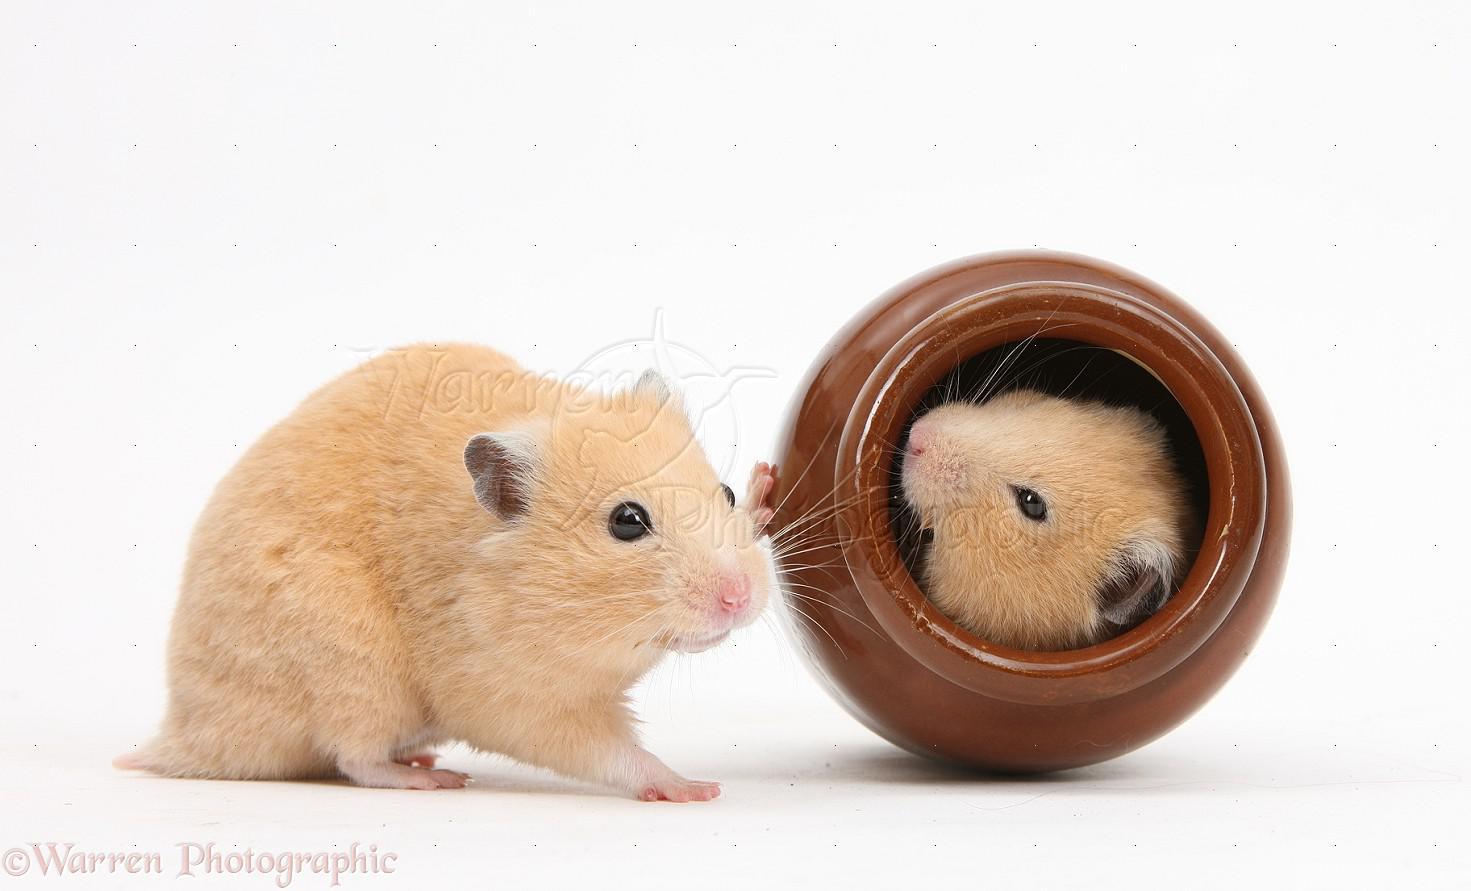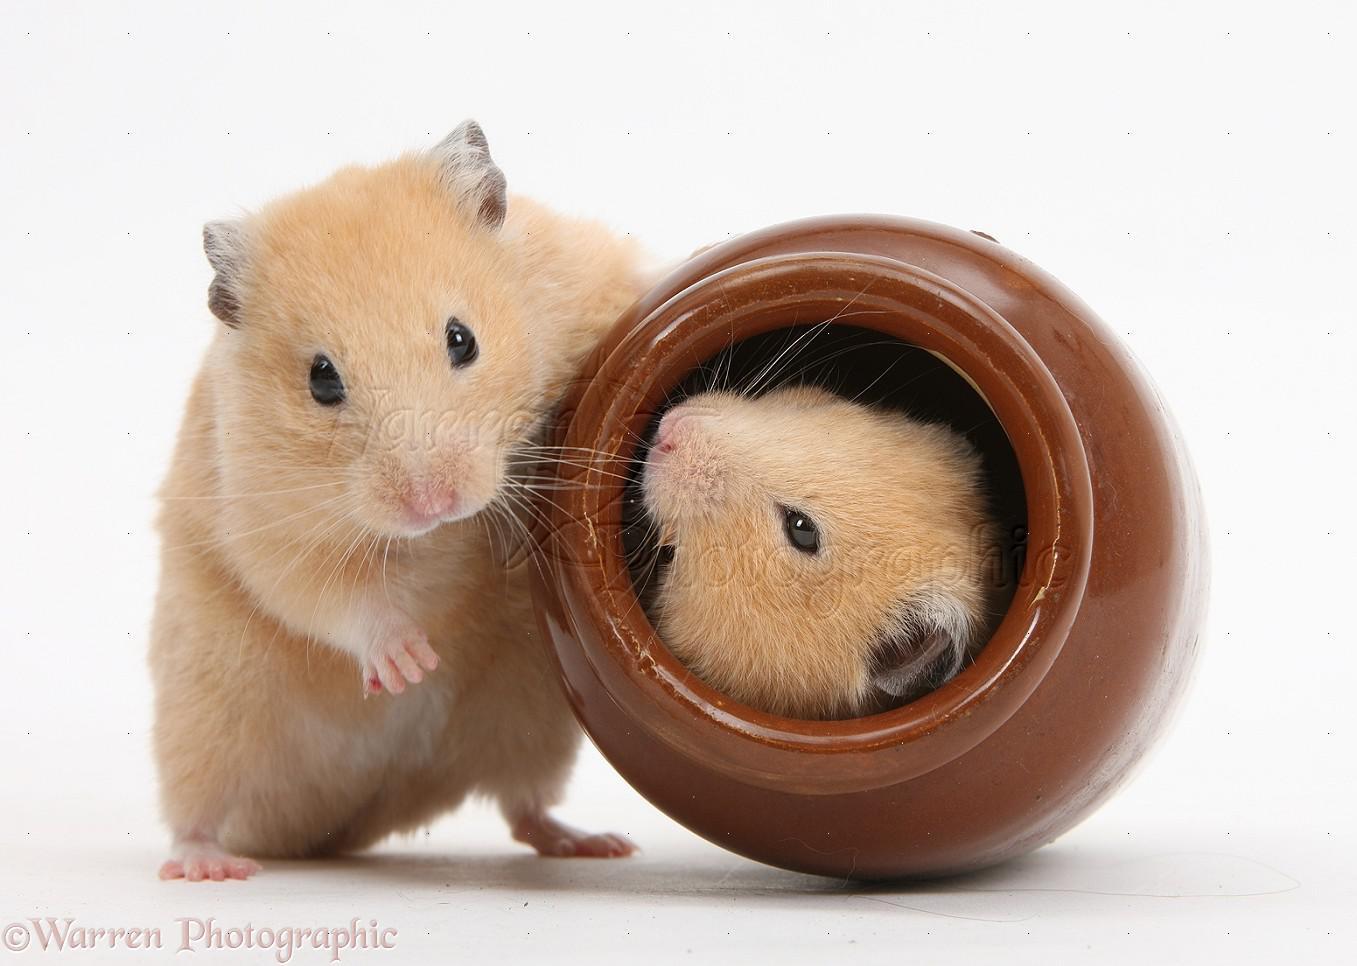The first image is the image on the left, the second image is the image on the right. Evaluate the accuracy of this statement regarding the images: "In at least one of the images, a small creature is interacting with a round object and the entire round object is visible.". Is it true? Answer yes or no. Yes. The first image is the image on the left, the second image is the image on the right. Assess this claim about the two images: "Each image contains exactly one pet rodent, and one of the animals poses bent forward with front paws off the ground and hind feet flat on the ground.". Correct or not? Answer yes or no. No. 